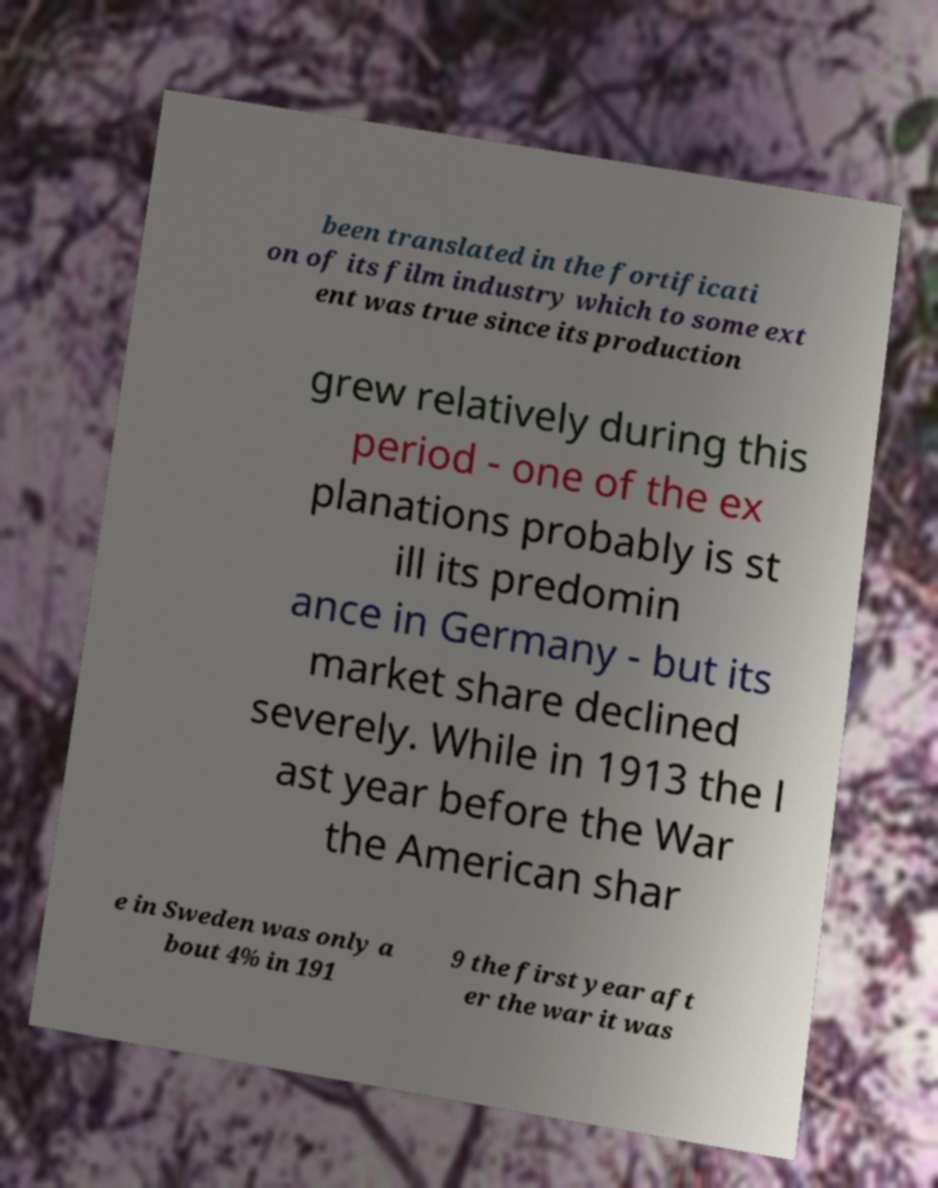Can you accurately transcribe the text from the provided image for me? been translated in the fortificati on of its film industry which to some ext ent was true since its production grew relatively during this period - one of the ex planations probably is st ill its predomin ance in Germany - but its market share declined severely. While in 1913 the l ast year before the War the American shar e in Sweden was only a bout 4% in 191 9 the first year aft er the war it was 